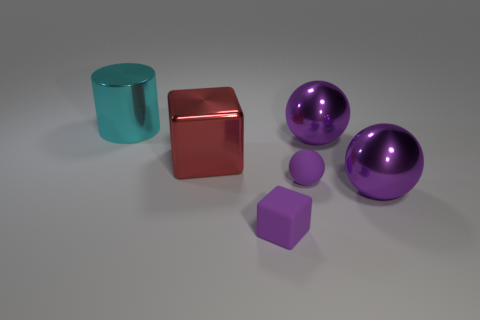Add 1 large metal balls. How many objects exist? 7 Subtract all cubes. How many objects are left? 4 Add 1 big purple rubber things. How many big purple rubber things exist? 1 Subtract 0 brown blocks. How many objects are left? 6 Subtract all small rubber blocks. Subtract all purple rubber spheres. How many objects are left? 4 Add 1 cylinders. How many cylinders are left? 2 